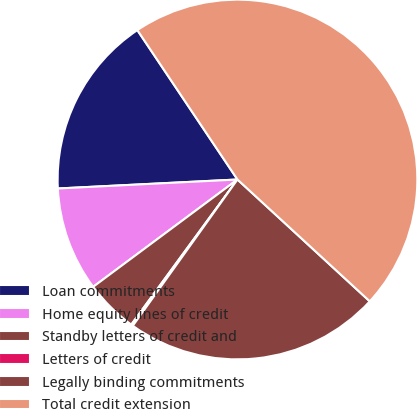Convert chart to OTSL. <chart><loc_0><loc_0><loc_500><loc_500><pie_chart><fcel>Loan commitments<fcel>Home equity lines of credit<fcel>Standby letters of credit and<fcel>Letters of credit<fcel>Legally binding commitments<fcel>Total credit extension<nl><fcel>16.4%<fcel>9.38%<fcel>4.77%<fcel>0.17%<fcel>23.04%<fcel>46.24%<nl></chart> 